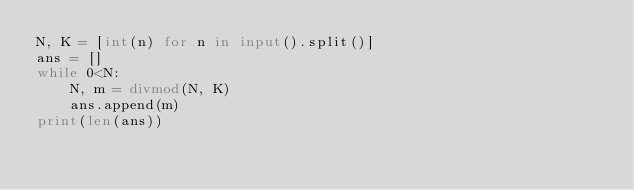Convert code to text. <code><loc_0><loc_0><loc_500><loc_500><_Python_>N, K = [int(n) for n in input().split()]
ans = []
while 0<N:
    N, m = divmod(N, K)
    ans.append(m)
print(len(ans))</code> 